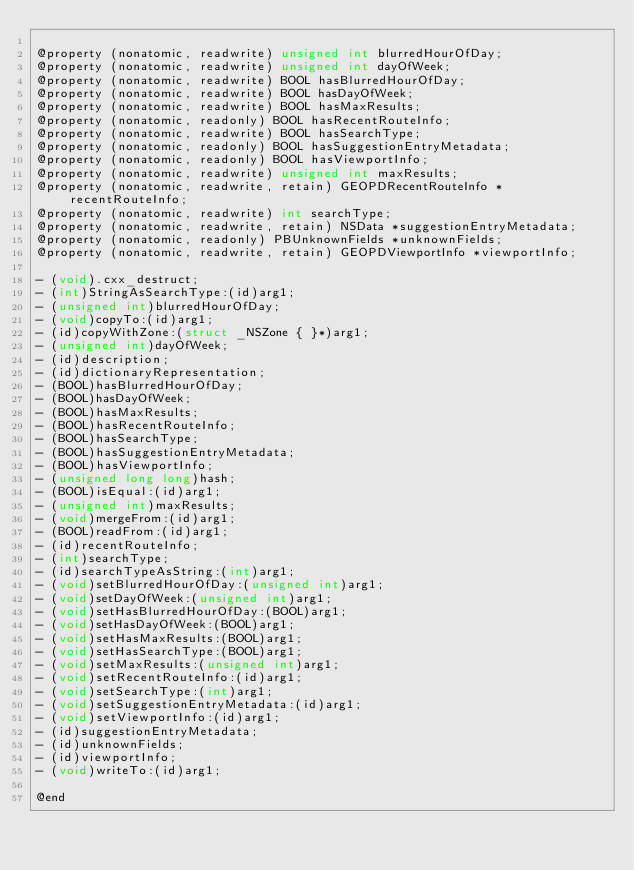Convert code to text. <code><loc_0><loc_0><loc_500><loc_500><_C_>
@property (nonatomic, readwrite) unsigned int blurredHourOfDay;
@property (nonatomic, readwrite) unsigned int dayOfWeek;
@property (nonatomic, readwrite) BOOL hasBlurredHourOfDay;
@property (nonatomic, readwrite) BOOL hasDayOfWeek;
@property (nonatomic, readwrite) BOOL hasMaxResults;
@property (nonatomic, readonly) BOOL hasRecentRouteInfo;
@property (nonatomic, readwrite) BOOL hasSearchType;
@property (nonatomic, readonly) BOOL hasSuggestionEntryMetadata;
@property (nonatomic, readonly) BOOL hasViewportInfo;
@property (nonatomic, readwrite) unsigned int maxResults;
@property (nonatomic, readwrite, retain) GEOPDRecentRouteInfo *recentRouteInfo;
@property (nonatomic, readwrite) int searchType;
@property (nonatomic, readwrite, retain) NSData *suggestionEntryMetadata;
@property (nonatomic, readonly) PBUnknownFields *unknownFields;
@property (nonatomic, readwrite, retain) GEOPDViewportInfo *viewportInfo;

- (void).cxx_destruct;
- (int)StringAsSearchType:(id)arg1;
- (unsigned int)blurredHourOfDay;
- (void)copyTo:(id)arg1;
- (id)copyWithZone:(struct _NSZone { }*)arg1;
- (unsigned int)dayOfWeek;
- (id)description;
- (id)dictionaryRepresentation;
- (BOOL)hasBlurredHourOfDay;
- (BOOL)hasDayOfWeek;
- (BOOL)hasMaxResults;
- (BOOL)hasRecentRouteInfo;
- (BOOL)hasSearchType;
- (BOOL)hasSuggestionEntryMetadata;
- (BOOL)hasViewportInfo;
- (unsigned long long)hash;
- (BOOL)isEqual:(id)arg1;
- (unsigned int)maxResults;
- (void)mergeFrom:(id)arg1;
- (BOOL)readFrom:(id)arg1;
- (id)recentRouteInfo;
- (int)searchType;
- (id)searchTypeAsString:(int)arg1;
- (void)setBlurredHourOfDay:(unsigned int)arg1;
- (void)setDayOfWeek:(unsigned int)arg1;
- (void)setHasBlurredHourOfDay:(BOOL)arg1;
- (void)setHasDayOfWeek:(BOOL)arg1;
- (void)setHasMaxResults:(BOOL)arg1;
- (void)setHasSearchType:(BOOL)arg1;
- (void)setMaxResults:(unsigned int)arg1;
- (void)setRecentRouteInfo:(id)arg1;
- (void)setSearchType:(int)arg1;
- (void)setSuggestionEntryMetadata:(id)arg1;
- (void)setViewportInfo:(id)arg1;
- (id)suggestionEntryMetadata;
- (id)unknownFields;
- (id)viewportInfo;
- (void)writeTo:(id)arg1;

@end
</code> 